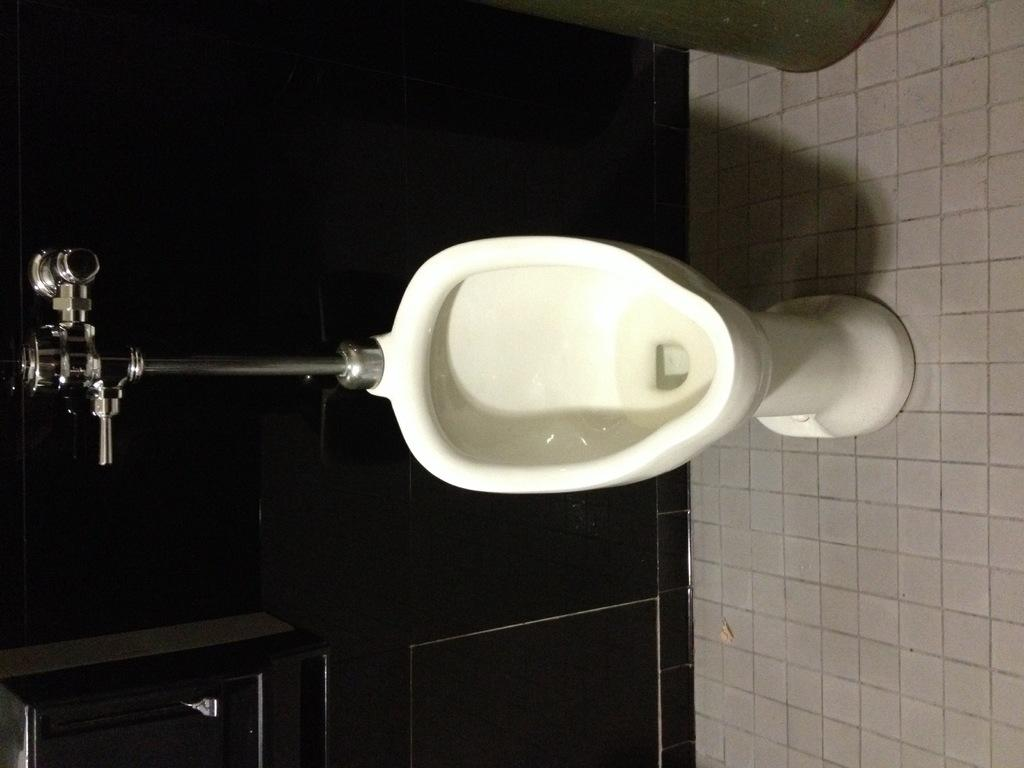What is the main object in the center of the image? There is a toilet seat in the center of the image. What can be seen on the left side of the image? There is a tap on the left side of the image. What part of the room is visible at the bottom of the image? There is a floor visible at the bottom of the image. What type of corn is growing on the edge of the image? There is no corn present in the image, and the edge of the image is not a location where plants would grow. 